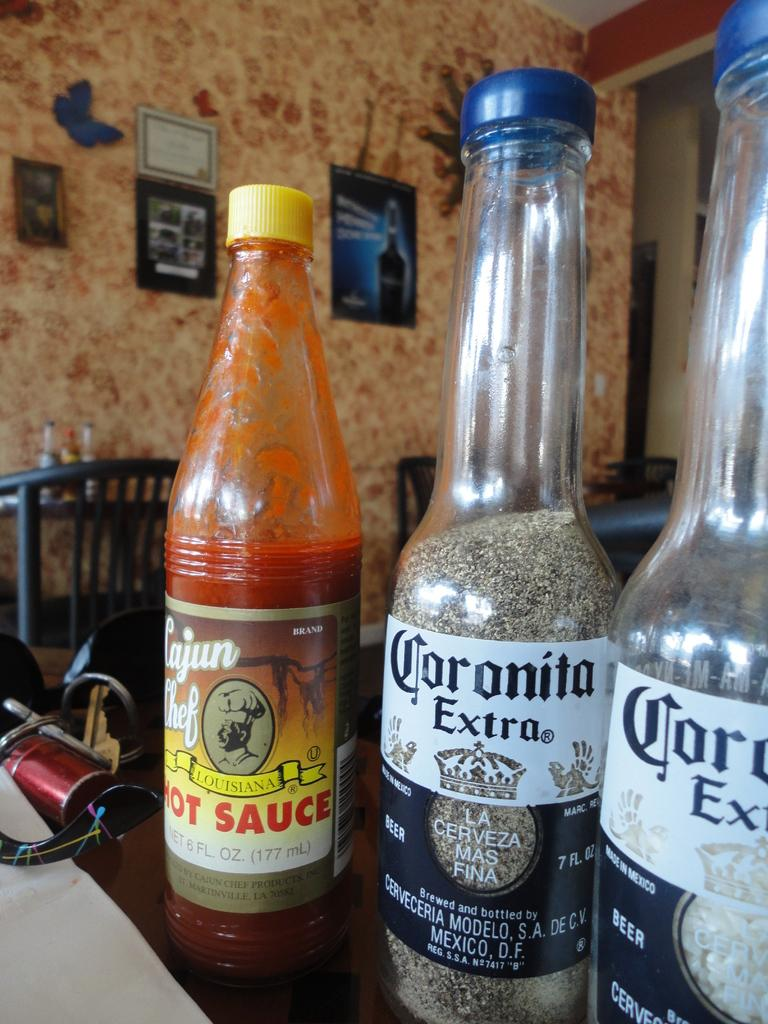<image>
Present a compact description of the photo's key features. A bottle of hot sauce is next to a couple of other bottles. 